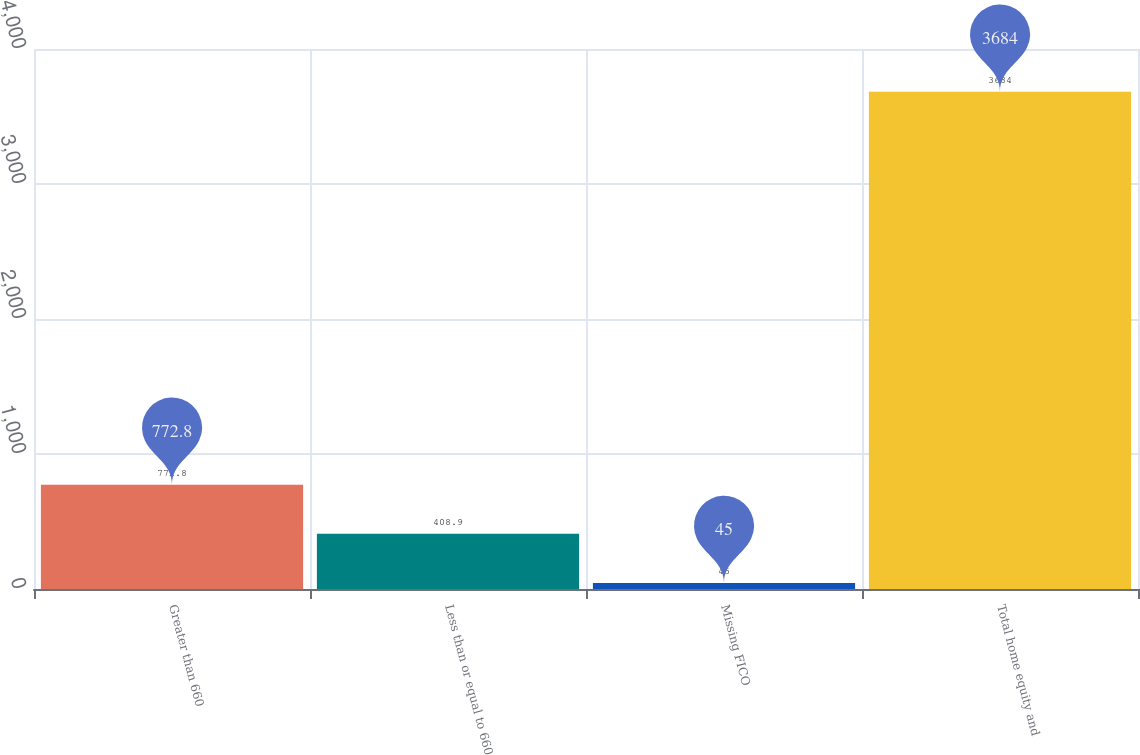Convert chart. <chart><loc_0><loc_0><loc_500><loc_500><bar_chart><fcel>Greater than 660<fcel>Less than or equal to 660<fcel>Missing FICO<fcel>Total home equity and<nl><fcel>772.8<fcel>408.9<fcel>45<fcel>3684<nl></chart> 